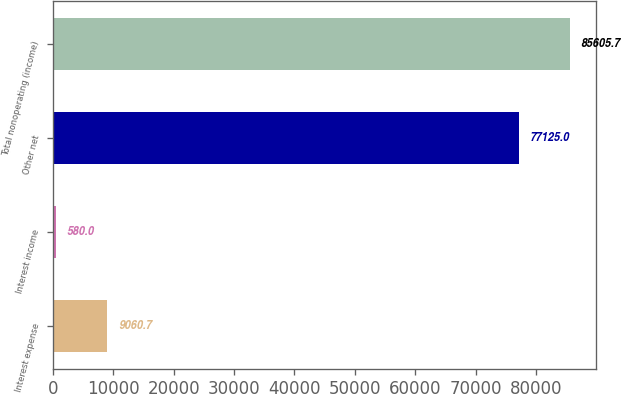Convert chart to OTSL. <chart><loc_0><loc_0><loc_500><loc_500><bar_chart><fcel>Interest expense<fcel>Interest income<fcel>Other net<fcel>Total nonoperating (income)<nl><fcel>9060.7<fcel>580<fcel>77125<fcel>85605.7<nl></chart> 